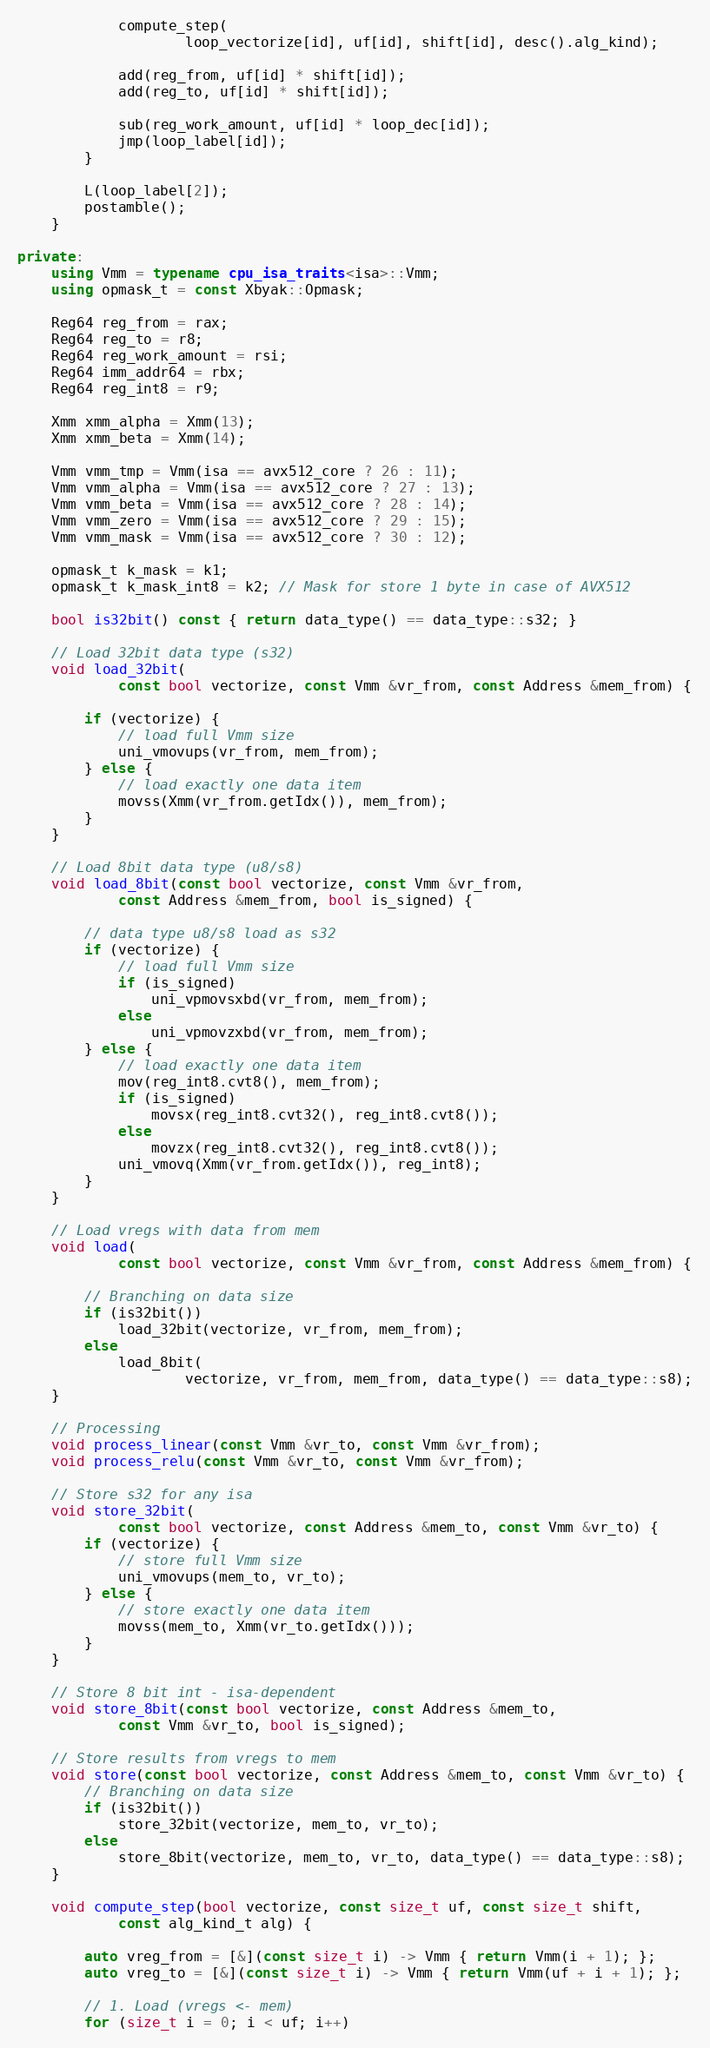Convert code to text. <code><loc_0><loc_0><loc_500><loc_500><_C++_>            compute_step(
                    loop_vectorize[id], uf[id], shift[id], desc().alg_kind);

            add(reg_from, uf[id] * shift[id]);
            add(reg_to, uf[id] * shift[id]);

            sub(reg_work_amount, uf[id] * loop_dec[id]);
            jmp(loop_label[id]);
        }

        L(loop_label[2]);
        postamble();
    }

private:
    using Vmm = typename cpu_isa_traits<isa>::Vmm;
    using opmask_t = const Xbyak::Opmask;

    Reg64 reg_from = rax;
    Reg64 reg_to = r8;
    Reg64 reg_work_amount = rsi;
    Reg64 imm_addr64 = rbx;
    Reg64 reg_int8 = r9;

    Xmm xmm_alpha = Xmm(13);
    Xmm xmm_beta = Xmm(14);

    Vmm vmm_tmp = Vmm(isa == avx512_core ? 26 : 11);
    Vmm vmm_alpha = Vmm(isa == avx512_core ? 27 : 13);
    Vmm vmm_beta = Vmm(isa == avx512_core ? 28 : 14);
    Vmm vmm_zero = Vmm(isa == avx512_core ? 29 : 15);
    Vmm vmm_mask = Vmm(isa == avx512_core ? 30 : 12);

    opmask_t k_mask = k1;
    opmask_t k_mask_int8 = k2; // Mask for store 1 byte in case of AVX512

    bool is32bit() const { return data_type() == data_type::s32; }

    // Load 32bit data type (s32)
    void load_32bit(
            const bool vectorize, const Vmm &vr_from, const Address &mem_from) {

        if (vectorize) {
            // load full Vmm size
            uni_vmovups(vr_from, mem_from);
        } else {
            // load exactly one data item
            movss(Xmm(vr_from.getIdx()), mem_from);
        }
    }

    // Load 8bit data type (u8/s8)
    void load_8bit(const bool vectorize, const Vmm &vr_from,
            const Address &mem_from, bool is_signed) {

        // data type u8/s8 load as s32
        if (vectorize) {
            // load full Vmm size
            if (is_signed)
                uni_vpmovsxbd(vr_from, mem_from);
            else
                uni_vpmovzxbd(vr_from, mem_from);
        } else {
            // load exactly one data item
            mov(reg_int8.cvt8(), mem_from);
            if (is_signed)
                movsx(reg_int8.cvt32(), reg_int8.cvt8());
            else
                movzx(reg_int8.cvt32(), reg_int8.cvt8());
            uni_vmovq(Xmm(vr_from.getIdx()), reg_int8);
        }
    }

    // Load vregs with data from mem
    void load(
            const bool vectorize, const Vmm &vr_from, const Address &mem_from) {

        // Branching on data size
        if (is32bit())
            load_32bit(vectorize, vr_from, mem_from);
        else
            load_8bit(
                    vectorize, vr_from, mem_from, data_type() == data_type::s8);
    }

    // Processing
    void process_linear(const Vmm &vr_to, const Vmm &vr_from);
    void process_relu(const Vmm &vr_to, const Vmm &vr_from);

    // Store s32 for any isa
    void store_32bit(
            const bool vectorize, const Address &mem_to, const Vmm &vr_to) {
        if (vectorize) {
            // store full Vmm size
            uni_vmovups(mem_to, vr_to);
        } else {
            // store exactly one data item
            movss(mem_to, Xmm(vr_to.getIdx()));
        }
    }

    // Store 8 bit int - isa-dependent
    void store_8bit(const bool vectorize, const Address &mem_to,
            const Vmm &vr_to, bool is_signed);

    // Store results from vregs to mem
    void store(const bool vectorize, const Address &mem_to, const Vmm &vr_to) {
        // Branching on data size
        if (is32bit())
            store_32bit(vectorize, mem_to, vr_to);
        else
            store_8bit(vectorize, mem_to, vr_to, data_type() == data_type::s8);
    }

    void compute_step(bool vectorize, const size_t uf, const size_t shift,
            const alg_kind_t alg) {

        auto vreg_from = [&](const size_t i) -> Vmm { return Vmm(i + 1); };
        auto vreg_to = [&](const size_t i) -> Vmm { return Vmm(uf + i + 1); };

        // 1. Load (vregs <- mem)
        for (size_t i = 0; i < uf; i++)</code> 